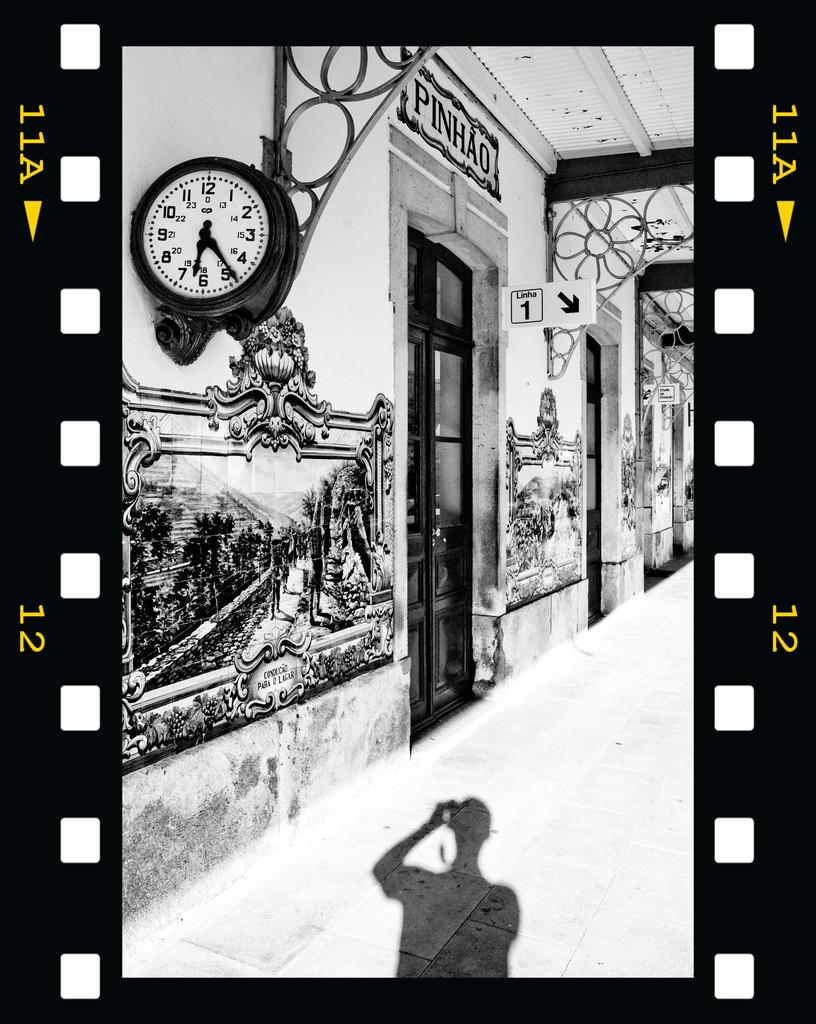<image>
Share a concise interpretation of the image provided. Outside of the Pinhao store with a large wall clock on the side. 